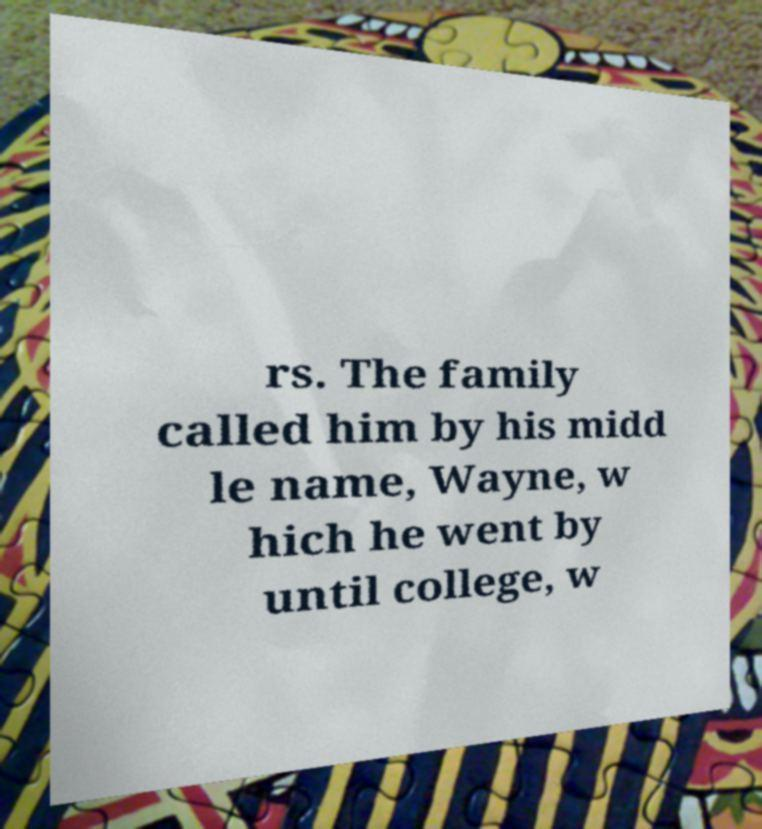Could you assist in decoding the text presented in this image and type it out clearly? rs. The family called him by his midd le name, Wayne, w hich he went by until college, w 